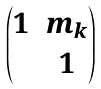<formula> <loc_0><loc_0><loc_500><loc_500>\begin{pmatrix} 1 & m _ { k } \\ & 1 \end{pmatrix}</formula> 